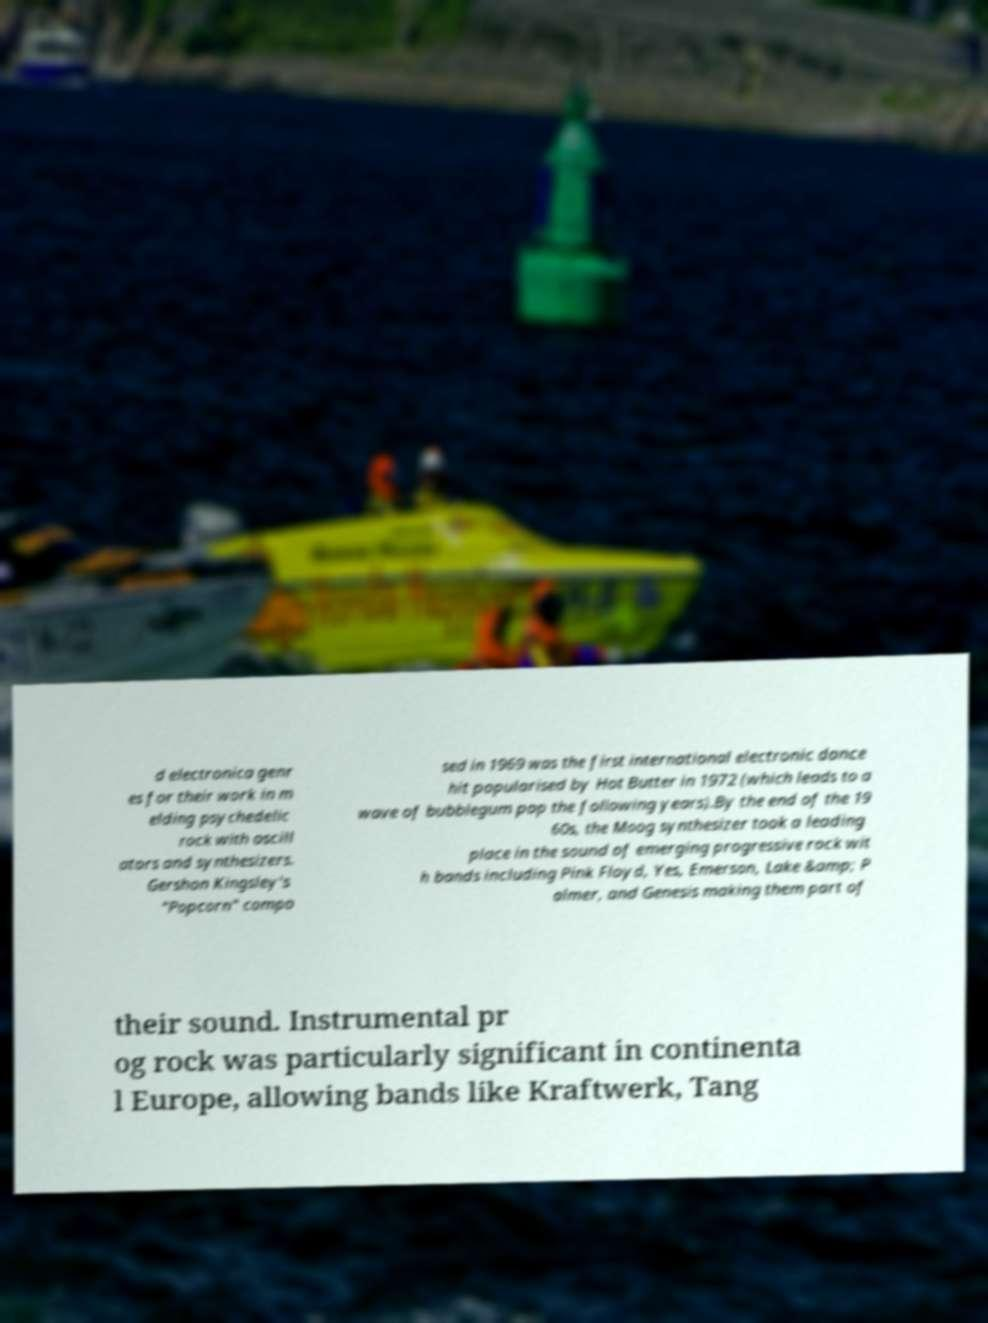Can you read and provide the text displayed in the image?This photo seems to have some interesting text. Can you extract and type it out for me? d electronica genr es for their work in m elding psychedelic rock with oscill ators and synthesizers. Gershon Kingsley's "Popcorn" compo sed in 1969 was the first international electronic dance hit popularised by Hot Butter in 1972 (which leads to a wave of bubblegum pop the following years).By the end of the 19 60s, the Moog synthesizer took a leading place in the sound of emerging progressive rock wit h bands including Pink Floyd, Yes, Emerson, Lake &amp; P almer, and Genesis making them part of their sound. Instrumental pr og rock was particularly significant in continenta l Europe, allowing bands like Kraftwerk, Tang 